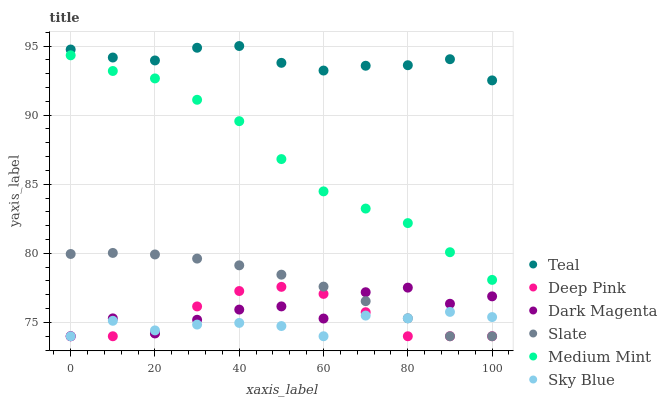Does Sky Blue have the minimum area under the curve?
Answer yes or no. Yes. Does Teal have the maximum area under the curve?
Answer yes or no. Yes. Does Deep Pink have the minimum area under the curve?
Answer yes or no. No. Does Deep Pink have the maximum area under the curve?
Answer yes or no. No. Is Slate the smoothest?
Answer yes or no. Yes. Is Dark Magenta the roughest?
Answer yes or no. Yes. Is Deep Pink the smoothest?
Answer yes or no. No. Is Deep Pink the roughest?
Answer yes or no. No. Does Deep Pink have the lowest value?
Answer yes or no. Yes. Does Teal have the lowest value?
Answer yes or no. No. Does Teal have the highest value?
Answer yes or no. Yes. Does Deep Pink have the highest value?
Answer yes or no. No. Is Deep Pink less than Medium Mint?
Answer yes or no. Yes. Is Medium Mint greater than Dark Magenta?
Answer yes or no. Yes. Does Deep Pink intersect Sky Blue?
Answer yes or no. Yes. Is Deep Pink less than Sky Blue?
Answer yes or no. No. Is Deep Pink greater than Sky Blue?
Answer yes or no. No. Does Deep Pink intersect Medium Mint?
Answer yes or no. No. 